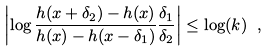<formula> <loc_0><loc_0><loc_500><loc_500>\left | \log \frac { h ( x + \delta _ { 2 } ) - h ( x ) } { h ( x ) - h ( x - \delta _ { 1 } ) } \frac { \delta _ { 1 } } { \delta _ { 2 } } \right | \leq \log ( k ) \ ,</formula> 